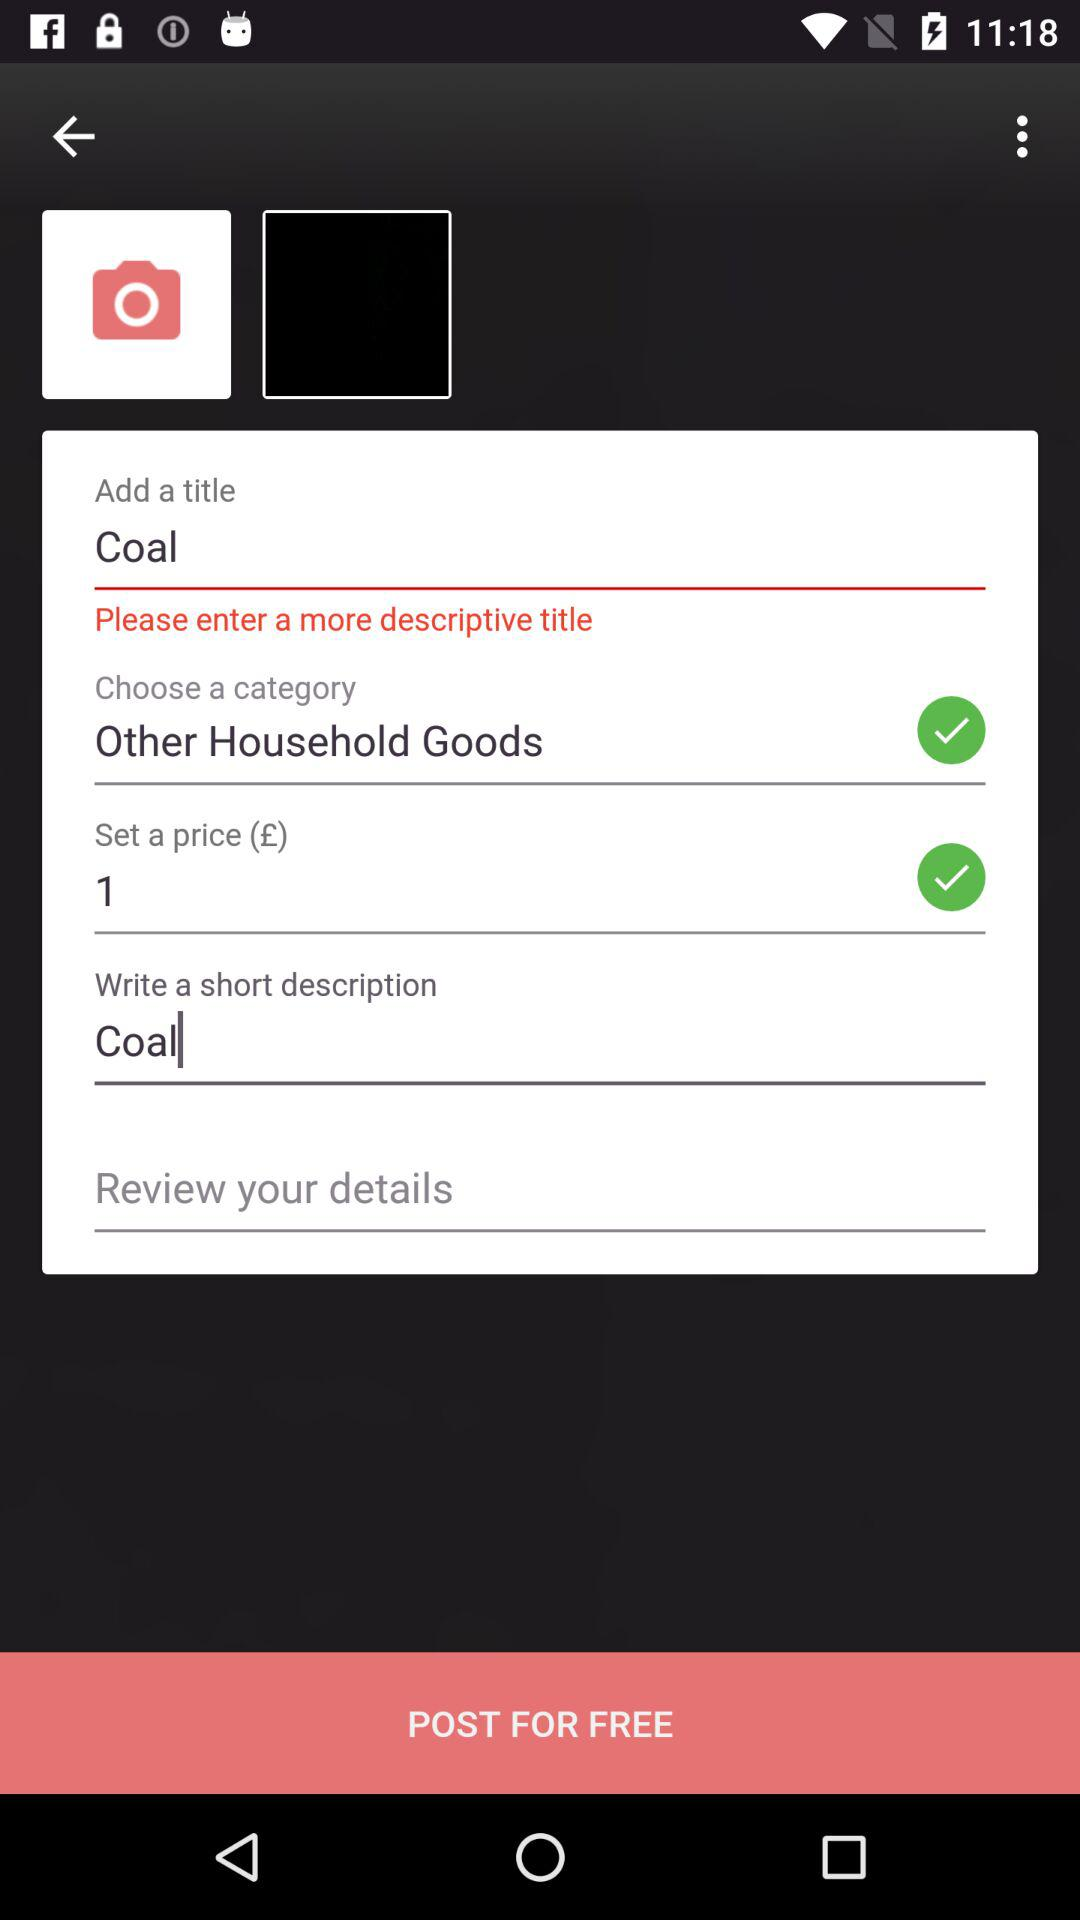What is the title? The title is "Coal". 